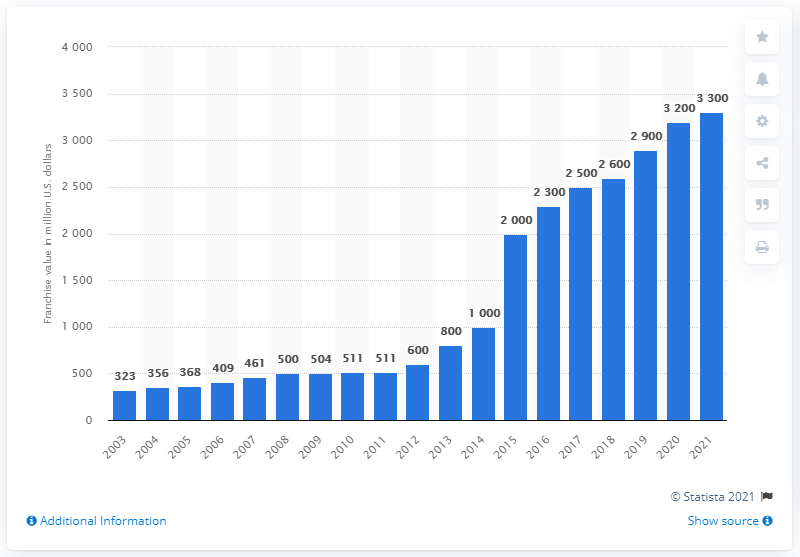What was the estimated value of the Chicago Bulls franchise in 2021?
 3300 